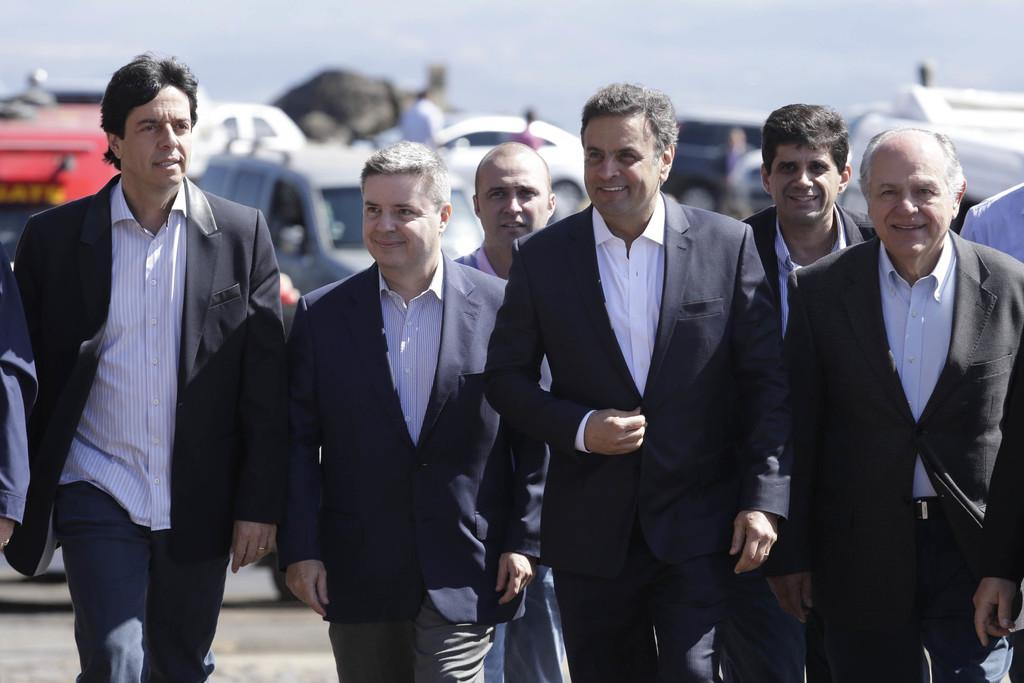What can be observed about the people in the image? There is a group of persons in the image, and they are smiling. What are the persons wearing in the image? The persons are wearing black color suits. What is visible in the background of the image? There is a vehicle and the sky visible in the background of the image. What type of station is the group of persons using in the image? There is no station present in the image; it features a group of persons wearing black suits and smiling. What role does the government play in the image? There is no mention of the government or its role in the image. 